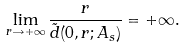Convert formula to latex. <formula><loc_0><loc_0><loc_500><loc_500>\lim _ { r \rightarrow + \infty } \frac { r } { \tilde { d } ( 0 , r ; A _ { s } ) } = + \infty .</formula> 